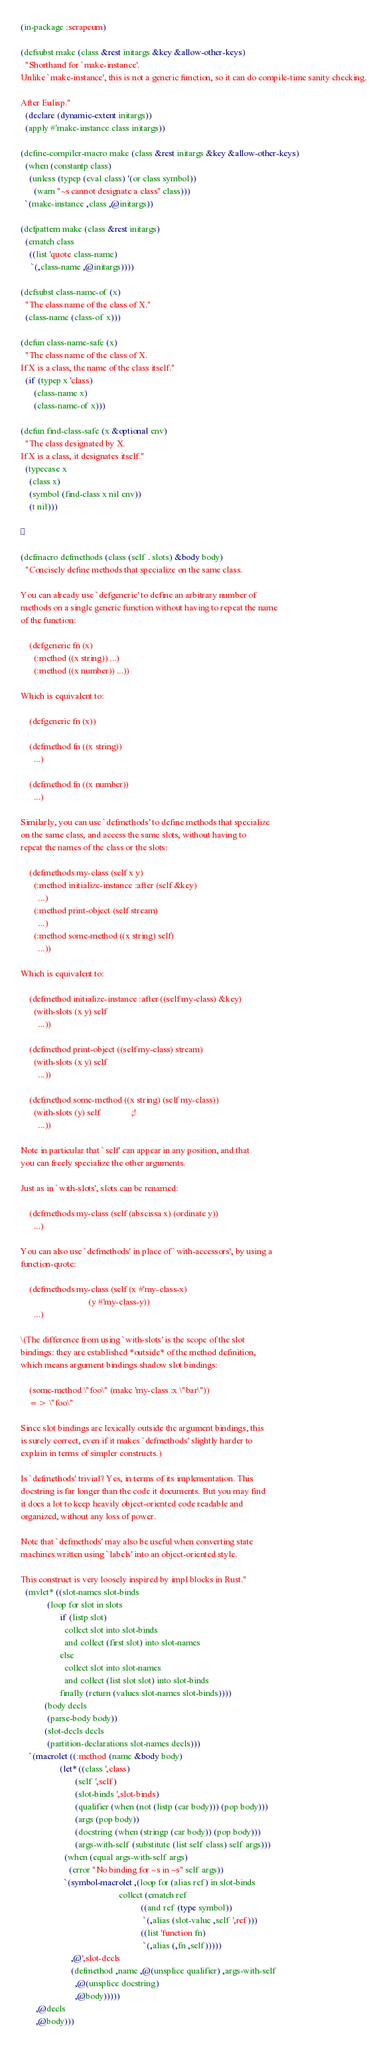<code> <loc_0><loc_0><loc_500><loc_500><_Lisp_>(in-package :serapeum)

(defsubst make (class &rest initargs &key &allow-other-keys)
  "Shorthand for `make-instance'.
Unlike `make-instance', this is not a generic function, so it can do compile-time sanity checking.

After Eulisp."
  (declare (dynamic-extent initargs))
  (apply #'make-instance class initargs))

(define-compiler-macro make (class &rest initargs &key &allow-other-keys)
  (when (constantp class)
    (unless (typep (eval class) '(or class symbol))
      (warn "~s cannot designate a class" class)))
  `(make-instance ,class ,@initargs))

(defpattern make (class &rest initargs)
  (ematch class
    ((list 'quote class-name)
     `(,class-name ,@initargs))))

(defsubst class-name-of (x)
  "The class name of the class of X."
  (class-name (class-of x)))

(defun class-name-safe (x)
  "The class name of the class of X.
If X is a class, the name of the class itself."
  (if (typep x 'class)
      (class-name x)
      (class-name-of x)))

(defun find-class-safe (x &optional env)
  "The class designated by X.
If X is a class, it designates itself."
  (typecase x
    (class x)
    (symbol (find-class x nil env))
    (t nil)))



(defmacro defmethods (class (self . slots) &body body)
  "Concisely define methods that specialize on the same class.

You can already use `defgeneric' to define an arbitrary number of
methods on a single generic function without having to repeat the name
of the function:

    (defgeneric fn (x)
      (:method ((x string)) ...)
      (:method ((x number)) ...))

Which is equivalent to:

    (defgeneric fn (x))

    (defmethod fn ((x string))
      ...)

    (defmethod fn ((x number))
      ...)

Similarly, you can use `defmethods' to define methods that specialize
on the same class, and access the same slots, without having to
repeat the names of the class or the slots:

    (defmethods my-class (self x y)
      (:method initialize-instance :after (self &key)
        ...)
      (:method print-object (self stream)
        ...)
      (:method some-method ((x string) self)
        ...))

Which is equivalent to:

    (defmethod initialize-instance :after ((self my-class) &key)
      (with-slots (x y) self
        ...))

    (defmethod print-object ((self my-class) stream)
      (with-slots (x y) self
        ...))

    (defmethod some-method ((x string) (self my-class))
      (with-slots (y) self              ;!
        ...))

Note in particular that `self' can appear in any position, and that
you can freely specialize the other arguments.

Just as in `with-slots', slots can be renamed:

    (defmethods my-class (self (abscissa x) (ordinate y))
      ...)

You can also use `defmethods' in place of `with-accessors', by using a
function-quote:

    (defmethods my-class (self (x #'my-class-x)
                               (y #'my-class-y))
      ...)

\(The difference from using `with-slots' is the scope of the slot
bindings: they are established *outside* of the method definition,
which means argument bindings shadow slot bindings:

    (some-method \"foo\" (make 'my-class :x \"bar\"))
    => \"foo\"

Since slot bindings are lexically outside the argument bindings, this
is surely correct, even if it makes `defmethods' slightly harder to
explain in terms of simpler constructs.)

Is `defmethods' trivial? Yes, in terms of its implementation. This
docstring is far longer than the code it documents. But you may find
it does a lot to keep heavily object-oriented code readable and
organized, without any loss of power.

Note that `defmethods' may also be useful when converting state
machines written using `labels' into an object-oriented style.

This construct is very loosely inspired by impl blocks in Rust."
  (mvlet* ((slot-names slot-binds
            (loop for slot in slots
                  if (listp slot)
                    collect slot into slot-binds
                    and collect (first slot) into slot-names
                  else
                    collect slot into slot-names
                    and collect (list slot slot) into slot-binds
                  finally (return (values slot-names slot-binds))))
           (body decls
            (parse-body body))
           (slot-decls decls
            (partition-declarations slot-names decls)))
    `(macrolet ((:method (name &body body)
                  (let* ((class ',class)
                         (self ',self)
                         (slot-binds ',slot-binds)
                         (qualifier (when (not (listp (car body))) (pop body)))
                         (args (pop body))
                         (docstring (when (stringp (car body)) (pop body)))
                         (args-with-self (substitute (list self class) self args)))
                    (when (equal args-with-self args)
                      (error "No binding for ~s in ~s" self args))
                    `(symbol-macrolet ,(loop for (alias ref) in slot-binds
                                             collect (ematch ref
                                                       ((and ref (type symbol))
                                                        `(,alias (slot-value ,self ',ref)))
                                                       ((list 'function fn)
                                                        `(,alias (,fn ,self)))))
                       ,@',slot-decls
                       (defmethod ,name ,@(unsplice qualifier) ,args-with-self
                         ,@(unsplice docstring)
                         ,@body)))))
       ,@decls
       ,@body)))
</code> 